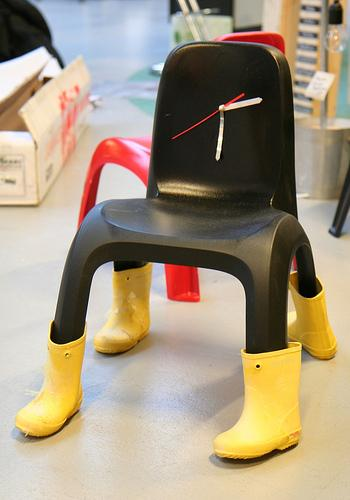State the material and color of the floor in the image. The floor is made of painted concrete and is off-white in color. Mention the location and appearance of the red chair in the image. The red chair, made of plastic, is located behind the black chair in the scene. Explain the object located to the right of the chairs. A metal waste paper basket is located to the right of the chairs, by the wall. Describe the objects on the black chair and their colors. There is a clock image, white hands on the clock, and red straw with a white zip tie on the black chair. What is placed on the legs of the black chair in the image? Yellow rain boots are placed on the legs of the black chair. Count the total number of chairs seen in the image and identify their colors. There are two chairs in the image - one black and one red. Mention two primary colors of the objects in the image. Black and yellow are the primary colors of objects in the image. Identify the color and contents of the box in the image. The box is white and has a red label on it, but its contents are not specified. What is the unusual object seen associated with the black chair in the image? The unusual object associated with the black chair is yellow rain boots on its legs. What type of boots are on the legs of the black chair? Light yellow rubber rain boots are on the legs of the black chair. 